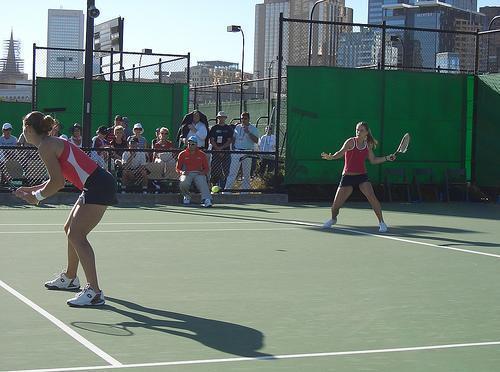How many people are wearing a red shirt?
Give a very brief answer. 4. 